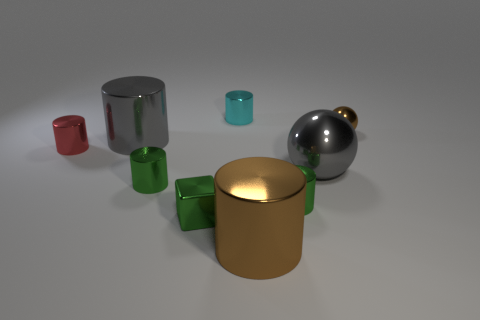Is there another red shiny cylinder that has the same size as the red shiny cylinder?
Your response must be concise. No. What is the color of the metallic sphere on the left side of the small brown shiny thing?
Provide a short and direct response. Gray. Are there any blocks that are left of the red thing behind the tiny green block?
Offer a terse response. No. How many other things are the same color as the tiny shiny sphere?
Ensure brevity in your answer.  1. There is a brown thing that is in front of the tiny brown object; does it have the same size as the ball in front of the tiny brown object?
Provide a succinct answer. Yes. There is a brown metal cylinder in front of the gray object that is to the right of the large brown metallic thing; what is its size?
Your answer should be compact. Large. The tiny metal sphere is what color?
Provide a succinct answer. Brown. What shape is the big gray shiny object right of the gray metallic cylinder?
Offer a terse response. Sphere. Are there any green objects that are to the left of the large shiny object left of the small cylinder that is behind the tiny red shiny object?
Your answer should be very brief. No. Is there a tiny metallic cylinder?
Provide a short and direct response. Yes. 